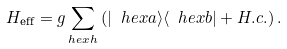<formula> <loc_0><loc_0><loc_500><loc_500>H _ { \text {eff} } = g \sum _ { h e x h } \left ( | \ h e x a \rangle \langle \ h e x b | + H . c . \right ) .</formula> 